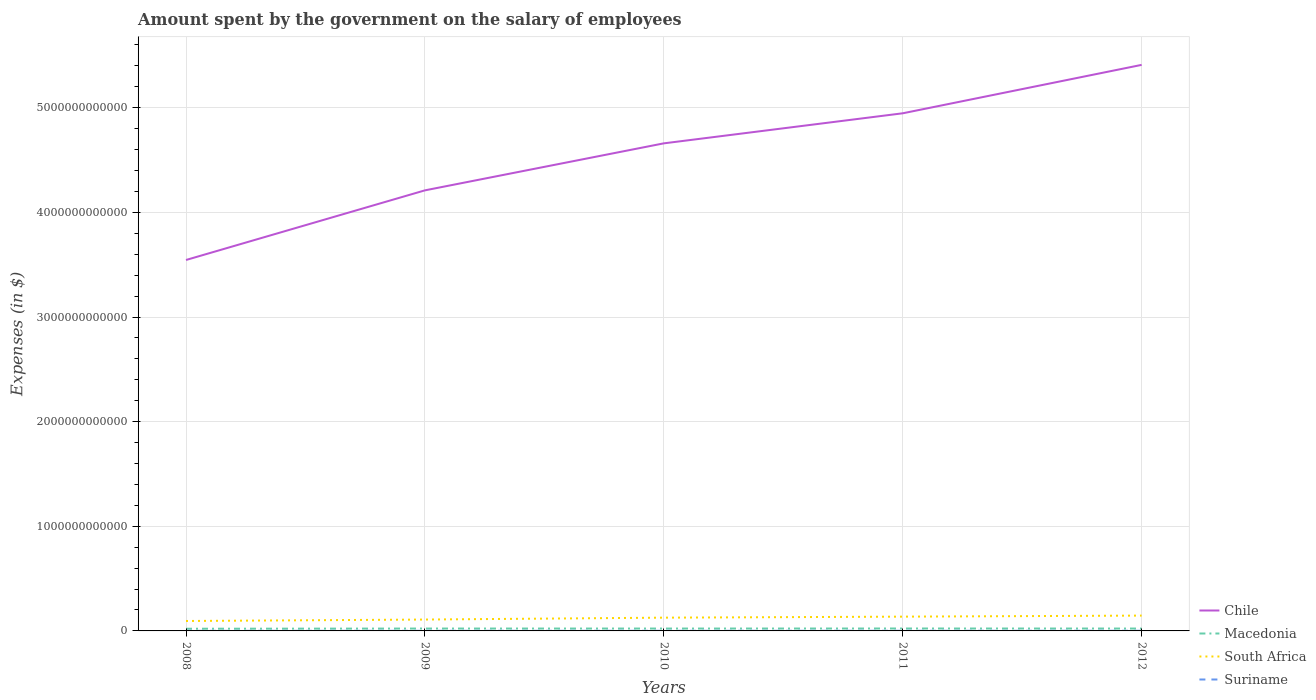Across all years, what is the maximum amount spent on the salary of employees by the government in Suriname?
Your answer should be very brief. 7.59e+08. What is the total amount spent on the salary of employees by the government in Chile in the graph?
Your response must be concise. -4.49e+11. What is the difference between the highest and the second highest amount spent on the salary of employees by the government in Macedonia?
Your answer should be very brief. 2.32e+09. What is the difference between the highest and the lowest amount spent on the salary of employees by the government in South Africa?
Make the answer very short. 3. Is the amount spent on the salary of employees by the government in Suriname strictly greater than the amount spent on the salary of employees by the government in Chile over the years?
Ensure brevity in your answer.  Yes. How many years are there in the graph?
Provide a short and direct response. 5. What is the difference between two consecutive major ticks on the Y-axis?
Provide a short and direct response. 1.00e+12. Are the values on the major ticks of Y-axis written in scientific E-notation?
Your response must be concise. No. What is the title of the graph?
Make the answer very short. Amount spent by the government on the salary of employees. Does "North America" appear as one of the legend labels in the graph?
Offer a terse response. No. What is the label or title of the Y-axis?
Make the answer very short. Expenses (in $). What is the Expenses (in $) in Chile in 2008?
Offer a terse response. 3.54e+12. What is the Expenses (in $) of Macedonia in 2008?
Keep it short and to the point. 2.08e+1. What is the Expenses (in $) of South Africa in 2008?
Give a very brief answer. 9.49e+1. What is the Expenses (in $) in Suriname in 2008?
Offer a terse response. 7.59e+08. What is the Expenses (in $) of Chile in 2009?
Make the answer very short. 4.21e+12. What is the Expenses (in $) in Macedonia in 2009?
Your answer should be compact. 2.27e+1. What is the Expenses (in $) of South Africa in 2009?
Ensure brevity in your answer.  1.09e+11. What is the Expenses (in $) in Suriname in 2009?
Keep it short and to the point. 9.68e+08. What is the Expenses (in $) of Chile in 2010?
Ensure brevity in your answer.  4.66e+12. What is the Expenses (in $) in Macedonia in 2010?
Ensure brevity in your answer.  2.26e+1. What is the Expenses (in $) of South Africa in 2010?
Provide a succinct answer. 1.27e+11. What is the Expenses (in $) in Suriname in 2010?
Provide a succinct answer. 1.08e+09. What is the Expenses (in $) of Chile in 2011?
Your answer should be very brief. 4.95e+12. What is the Expenses (in $) in Macedonia in 2011?
Your response must be concise. 2.31e+1. What is the Expenses (in $) of South Africa in 2011?
Make the answer very short. 1.36e+11. What is the Expenses (in $) in Suriname in 2011?
Offer a very short reply. 1.21e+09. What is the Expenses (in $) in Chile in 2012?
Provide a short and direct response. 5.41e+12. What is the Expenses (in $) of Macedonia in 2012?
Offer a terse response. 2.27e+1. What is the Expenses (in $) of South Africa in 2012?
Give a very brief answer. 1.47e+11. What is the Expenses (in $) of Suriname in 2012?
Provide a short and direct response. 1.32e+09. Across all years, what is the maximum Expenses (in $) of Chile?
Keep it short and to the point. 5.41e+12. Across all years, what is the maximum Expenses (in $) in Macedonia?
Keep it short and to the point. 2.31e+1. Across all years, what is the maximum Expenses (in $) of South Africa?
Your answer should be compact. 1.47e+11. Across all years, what is the maximum Expenses (in $) of Suriname?
Your answer should be compact. 1.32e+09. Across all years, what is the minimum Expenses (in $) of Chile?
Ensure brevity in your answer.  3.54e+12. Across all years, what is the minimum Expenses (in $) in Macedonia?
Keep it short and to the point. 2.08e+1. Across all years, what is the minimum Expenses (in $) of South Africa?
Offer a terse response. 9.49e+1. Across all years, what is the minimum Expenses (in $) in Suriname?
Keep it short and to the point. 7.59e+08. What is the total Expenses (in $) of Chile in the graph?
Offer a terse response. 2.28e+13. What is the total Expenses (in $) in Macedonia in the graph?
Ensure brevity in your answer.  1.12e+11. What is the total Expenses (in $) of South Africa in the graph?
Give a very brief answer. 6.13e+11. What is the total Expenses (in $) of Suriname in the graph?
Keep it short and to the point. 5.33e+09. What is the difference between the Expenses (in $) of Chile in 2008 and that in 2009?
Your answer should be compact. -6.66e+11. What is the difference between the Expenses (in $) in Macedonia in 2008 and that in 2009?
Give a very brief answer. -1.87e+09. What is the difference between the Expenses (in $) of South Africa in 2008 and that in 2009?
Offer a very short reply. -1.38e+1. What is the difference between the Expenses (in $) in Suriname in 2008 and that in 2009?
Your answer should be compact. -2.09e+08. What is the difference between the Expenses (in $) in Chile in 2008 and that in 2010?
Offer a terse response. -1.11e+12. What is the difference between the Expenses (in $) of Macedonia in 2008 and that in 2010?
Your answer should be very brief. -1.81e+09. What is the difference between the Expenses (in $) of South Africa in 2008 and that in 2010?
Provide a succinct answer. -3.18e+1. What is the difference between the Expenses (in $) in Suriname in 2008 and that in 2010?
Provide a succinct answer. -3.17e+08. What is the difference between the Expenses (in $) in Chile in 2008 and that in 2011?
Ensure brevity in your answer.  -1.40e+12. What is the difference between the Expenses (in $) of Macedonia in 2008 and that in 2011?
Offer a terse response. -2.32e+09. What is the difference between the Expenses (in $) in South Africa in 2008 and that in 2011?
Offer a terse response. -4.15e+1. What is the difference between the Expenses (in $) of Suriname in 2008 and that in 2011?
Provide a short and direct response. -4.50e+08. What is the difference between the Expenses (in $) of Chile in 2008 and that in 2012?
Offer a terse response. -1.86e+12. What is the difference between the Expenses (in $) of Macedonia in 2008 and that in 2012?
Give a very brief answer. -1.89e+09. What is the difference between the Expenses (in $) in South Africa in 2008 and that in 2012?
Your answer should be very brief. -5.16e+1. What is the difference between the Expenses (in $) in Suriname in 2008 and that in 2012?
Your answer should be very brief. -5.57e+08. What is the difference between the Expenses (in $) of Chile in 2009 and that in 2010?
Your response must be concise. -4.49e+11. What is the difference between the Expenses (in $) of Macedonia in 2009 and that in 2010?
Give a very brief answer. 6.10e+07. What is the difference between the Expenses (in $) of South Africa in 2009 and that in 2010?
Keep it short and to the point. -1.81e+1. What is the difference between the Expenses (in $) in Suriname in 2009 and that in 2010?
Give a very brief answer. -1.07e+08. What is the difference between the Expenses (in $) in Chile in 2009 and that in 2011?
Your answer should be compact. -7.36e+11. What is the difference between the Expenses (in $) in Macedonia in 2009 and that in 2011?
Offer a terse response. -4.48e+08. What is the difference between the Expenses (in $) in South Africa in 2009 and that in 2011?
Make the answer very short. -2.78e+1. What is the difference between the Expenses (in $) of Suriname in 2009 and that in 2011?
Ensure brevity in your answer.  -2.41e+08. What is the difference between the Expenses (in $) of Chile in 2009 and that in 2012?
Provide a short and direct response. -1.20e+12. What is the difference between the Expenses (in $) in Macedonia in 2009 and that in 2012?
Offer a very short reply. -1.50e+07. What is the difference between the Expenses (in $) of South Africa in 2009 and that in 2012?
Provide a short and direct response. -3.78e+1. What is the difference between the Expenses (in $) in Suriname in 2009 and that in 2012?
Your response must be concise. -3.48e+08. What is the difference between the Expenses (in $) in Chile in 2010 and that in 2011?
Offer a terse response. -2.87e+11. What is the difference between the Expenses (in $) of Macedonia in 2010 and that in 2011?
Provide a short and direct response. -5.09e+08. What is the difference between the Expenses (in $) of South Africa in 2010 and that in 2011?
Keep it short and to the point. -9.72e+09. What is the difference between the Expenses (in $) in Suriname in 2010 and that in 2011?
Make the answer very short. -1.34e+08. What is the difference between the Expenses (in $) in Chile in 2010 and that in 2012?
Give a very brief answer. -7.50e+11. What is the difference between the Expenses (in $) in Macedonia in 2010 and that in 2012?
Offer a very short reply. -7.60e+07. What is the difference between the Expenses (in $) in South Africa in 2010 and that in 2012?
Make the answer very short. -1.98e+1. What is the difference between the Expenses (in $) of Suriname in 2010 and that in 2012?
Make the answer very short. -2.40e+08. What is the difference between the Expenses (in $) of Chile in 2011 and that in 2012?
Ensure brevity in your answer.  -4.63e+11. What is the difference between the Expenses (in $) in Macedonia in 2011 and that in 2012?
Keep it short and to the point. 4.33e+08. What is the difference between the Expenses (in $) of South Africa in 2011 and that in 2012?
Offer a very short reply. -1.01e+1. What is the difference between the Expenses (in $) in Suriname in 2011 and that in 2012?
Your response must be concise. -1.07e+08. What is the difference between the Expenses (in $) in Chile in 2008 and the Expenses (in $) in Macedonia in 2009?
Offer a terse response. 3.52e+12. What is the difference between the Expenses (in $) of Chile in 2008 and the Expenses (in $) of South Africa in 2009?
Your response must be concise. 3.44e+12. What is the difference between the Expenses (in $) in Chile in 2008 and the Expenses (in $) in Suriname in 2009?
Your answer should be compact. 3.54e+12. What is the difference between the Expenses (in $) in Macedonia in 2008 and the Expenses (in $) in South Africa in 2009?
Give a very brief answer. -8.79e+1. What is the difference between the Expenses (in $) of Macedonia in 2008 and the Expenses (in $) of Suriname in 2009?
Provide a short and direct response. 1.99e+1. What is the difference between the Expenses (in $) of South Africa in 2008 and the Expenses (in $) of Suriname in 2009?
Keep it short and to the point. 9.40e+1. What is the difference between the Expenses (in $) in Chile in 2008 and the Expenses (in $) in Macedonia in 2010?
Your answer should be compact. 3.52e+12. What is the difference between the Expenses (in $) in Chile in 2008 and the Expenses (in $) in South Africa in 2010?
Give a very brief answer. 3.42e+12. What is the difference between the Expenses (in $) of Chile in 2008 and the Expenses (in $) of Suriname in 2010?
Provide a succinct answer. 3.54e+12. What is the difference between the Expenses (in $) in Macedonia in 2008 and the Expenses (in $) in South Africa in 2010?
Provide a short and direct response. -1.06e+11. What is the difference between the Expenses (in $) of Macedonia in 2008 and the Expenses (in $) of Suriname in 2010?
Give a very brief answer. 1.98e+1. What is the difference between the Expenses (in $) of South Africa in 2008 and the Expenses (in $) of Suriname in 2010?
Make the answer very short. 9.39e+1. What is the difference between the Expenses (in $) of Chile in 2008 and the Expenses (in $) of Macedonia in 2011?
Your response must be concise. 3.52e+12. What is the difference between the Expenses (in $) in Chile in 2008 and the Expenses (in $) in South Africa in 2011?
Offer a very short reply. 3.41e+12. What is the difference between the Expenses (in $) of Chile in 2008 and the Expenses (in $) of Suriname in 2011?
Ensure brevity in your answer.  3.54e+12. What is the difference between the Expenses (in $) in Macedonia in 2008 and the Expenses (in $) in South Africa in 2011?
Give a very brief answer. -1.16e+11. What is the difference between the Expenses (in $) of Macedonia in 2008 and the Expenses (in $) of Suriname in 2011?
Your answer should be compact. 1.96e+1. What is the difference between the Expenses (in $) in South Africa in 2008 and the Expenses (in $) in Suriname in 2011?
Your answer should be very brief. 9.37e+1. What is the difference between the Expenses (in $) of Chile in 2008 and the Expenses (in $) of Macedonia in 2012?
Offer a very short reply. 3.52e+12. What is the difference between the Expenses (in $) of Chile in 2008 and the Expenses (in $) of South Africa in 2012?
Provide a short and direct response. 3.40e+12. What is the difference between the Expenses (in $) of Chile in 2008 and the Expenses (in $) of Suriname in 2012?
Provide a succinct answer. 3.54e+12. What is the difference between the Expenses (in $) of Macedonia in 2008 and the Expenses (in $) of South Africa in 2012?
Your answer should be compact. -1.26e+11. What is the difference between the Expenses (in $) of Macedonia in 2008 and the Expenses (in $) of Suriname in 2012?
Your answer should be compact. 1.95e+1. What is the difference between the Expenses (in $) in South Africa in 2008 and the Expenses (in $) in Suriname in 2012?
Keep it short and to the point. 9.36e+1. What is the difference between the Expenses (in $) in Chile in 2009 and the Expenses (in $) in Macedonia in 2010?
Provide a succinct answer. 4.19e+12. What is the difference between the Expenses (in $) in Chile in 2009 and the Expenses (in $) in South Africa in 2010?
Provide a short and direct response. 4.08e+12. What is the difference between the Expenses (in $) in Chile in 2009 and the Expenses (in $) in Suriname in 2010?
Offer a very short reply. 4.21e+12. What is the difference between the Expenses (in $) in Macedonia in 2009 and the Expenses (in $) in South Africa in 2010?
Your answer should be very brief. -1.04e+11. What is the difference between the Expenses (in $) of Macedonia in 2009 and the Expenses (in $) of Suriname in 2010?
Your answer should be compact. 2.16e+1. What is the difference between the Expenses (in $) in South Africa in 2009 and the Expenses (in $) in Suriname in 2010?
Provide a short and direct response. 1.08e+11. What is the difference between the Expenses (in $) in Chile in 2009 and the Expenses (in $) in Macedonia in 2011?
Give a very brief answer. 4.19e+12. What is the difference between the Expenses (in $) of Chile in 2009 and the Expenses (in $) of South Africa in 2011?
Give a very brief answer. 4.07e+12. What is the difference between the Expenses (in $) of Chile in 2009 and the Expenses (in $) of Suriname in 2011?
Make the answer very short. 4.21e+12. What is the difference between the Expenses (in $) in Macedonia in 2009 and the Expenses (in $) in South Africa in 2011?
Provide a short and direct response. -1.14e+11. What is the difference between the Expenses (in $) in Macedonia in 2009 and the Expenses (in $) in Suriname in 2011?
Your answer should be very brief. 2.15e+1. What is the difference between the Expenses (in $) of South Africa in 2009 and the Expenses (in $) of Suriname in 2011?
Provide a short and direct response. 1.07e+11. What is the difference between the Expenses (in $) of Chile in 2009 and the Expenses (in $) of Macedonia in 2012?
Your answer should be compact. 4.19e+12. What is the difference between the Expenses (in $) of Chile in 2009 and the Expenses (in $) of South Africa in 2012?
Ensure brevity in your answer.  4.06e+12. What is the difference between the Expenses (in $) of Chile in 2009 and the Expenses (in $) of Suriname in 2012?
Offer a very short reply. 4.21e+12. What is the difference between the Expenses (in $) of Macedonia in 2009 and the Expenses (in $) of South Africa in 2012?
Provide a short and direct response. -1.24e+11. What is the difference between the Expenses (in $) in Macedonia in 2009 and the Expenses (in $) in Suriname in 2012?
Your answer should be very brief. 2.14e+1. What is the difference between the Expenses (in $) of South Africa in 2009 and the Expenses (in $) of Suriname in 2012?
Your answer should be very brief. 1.07e+11. What is the difference between the Expenses (in $) of Chile in 2010 and the Expenses (in $) of Macedonia in 2011?
Provide a short and direct response. 4.64e+12. What is the difference between the Expenses (in $) in Chile in 2010 and the Expenses (in $) in South Africa in 2011?
Ensure brevity in your answer.  4.52e+12. What is the difference between the Expenses (in $) in Chile in 2010 and the Expenses (in $) in Suriname in 2011?
Your answer should be very brief. 4.66e+12. What is the difference between the Expenses (in $) of Macedonia in 2010 and the Expenses (in $) of South Africa in 2011?
Ensure brevity in your answer.  -1.14e+11. What is the difference between the Expenses (in $) of Macedonia in 2010 and the Expenses (in $) of Suriname in 2011?
Make the answer very short. 2.14e+1. What is the difference between the Expenses (in $) in South Africa in 2010 and the Expenses (in $) in Suriname in 2011?
Your response must be concise. 1.26e+11. What is the difference between the Expenses (in $) of Chile in 2010 and the Expenses (in $) of Macedonia in 2012?
Your answer should be very brief. 4.64e+12. What is the difference between the Expenses (in $) in Chile in 2010 and the Expenses (in $) in South Africa in 2012?
Offer a terse response. 4.51e+12. What is the difference between the Expenses (in $) of Chile in 2010 and the Expenses (in $) of Suriname in 2012?
Ensure brevity in your answer.  4.66e+12. What is the difference between the Expenses (in $) in Macedonia in 2010 and the Expenses (in $) in South Africa in 2012?
Your answer should be compact. -1.24e+11. What is the difference between the Expenses (in $) in Macedonia in 2010 and the Expenses (in $) in Suriname in 2012?
Your response must be concise. 2.13e+1. What is the difference between the Expenses (in $) in South Africa in 2010 and the Expenses (in $) in Suriname in 2012?
Provide a short and direct response. 1.25e+11. What is the difference between the Expenses (in $) in Chile in 2011 and the Expenses (in $) in Macedonia in 2012?
Ensure brevity in your answer.  4.92e+12. What is the difference between the Expenses (in $) of Chile in 2011 and the Expenses (in $) of South Africa in 2012?
Provide a short and direct response. 4.80e+12. What is the difference between the Expenses (in $) of Chile in 2011 and the Expenses (in $) of Suriname in 2012?
Provide a succinct answer. 4.95e+12. What is the difference between the Expenses (in $) of Macedonia in 2011 and the Expenses (in $) of South Africa in 2012?
Your response must be concise. -1.23e+11. What is the difference between the Expenses (in $) in Macedonia in 2011 and the Expenses (in $) in Suriname in 2012?
Ensure brevity in your answer.  2.18e+1. What is the difference between the Expenses (in $) of South Africa in 2011 and the Expenses (in $) of Suriname in 2012?
Make the answer very short. 1.35e+11. What is the average Expenses (in $) in Chile per year?
Offer a very short reply. 4.55e+12. What is the average Expenses (in $) of Macedonia per year?
Ensure brevity in your answer.  2.24e+1. What is the average Expenses (in $) of South Africa per year?
Keep it short and to the point. 1.23e+11. What is the average Expenses (in $) in Suriname per year?
Keep it short and to the point. 1.07e+09. In the year 2008, what is the difference between the Expenses (in $) in Chile and Expenses (in $) in Macedonia?
Make the answer very short. 3.52e+12. In the year 2008, what is the difference between the Expenses (in $) in Chile and Expenses (in $) in South Africa?
Make the answer very short. 3.45e+12. In the year 2008, what is the difference between the Expenses (in $) in Chile and Expenses (in $) in Suriname?
Make the answer very short. 3.54e+12. In the year 2008, what is the difference between the Expenses (in $) in Macedonia and Expenses (in $) in South Africa?
Your answer should be compact. -7.41e+1. In the year 2008, what is the difference between the Expenses (in $) of Macedonia and Expenses (in $) of Suriname?
Ensure brevity in your answer.  2.01e+1. In the year 2008, what is the difference between the Expenses (in $) of South Africa and Expenses (in $) of Suriname?
Offer a very short reply. 9.42e+1. In the year 2009, what is the difference between the Expenses (in $) of Chile and Expenses (in $) of Macedonia?
Provide a succinct answer. 4.19e+12. In the year 2009, what is the difference between the Expenses (in $) of Chile and Expenses (in $) of South Africa?
Offer a terse response. 4.10e+12. In the year 2009, what is the difference between the Expenses (in $) of Chile and Expenses (in $) of Suriname?
Keep it short and to the point. 4.21e+12. In the year 2009, what is the difference between the Expenses (in $) of Macedonia and Expenses (in $) of South Africa?
Give a very brief answer. -8.60e+1. In the year 2009, what is the difference between the Expenses (in $) in Macedonia and Expenses (in $) in Suriname?
Your answer should be very brief. 2.17e+1. In the year 2009, what is the difference between the Expenses (in $) of South Africa and Expenses (in $) of Suriname?
Offer a very short reply. 1.08e+11. In the year 2010, what is the difference between the Expenses (in $) of Chile and Expenses (in $) of Macedonia?
Offer a very short reply. 4.64e+12. In the year 2010, what is the difference between the Expenses (in $) in Chile and Expenses (in $) in South Africa?
Your response must be concise. 4.53e+12. In the year 2010, what is the difference between the Expenses (in $) of Chile and Expenses (in $) of Suriname?
Make the answer very short. 4.66e+12. In the year 2010, what is the difference between the Expenses (in $) of Macedonia and Expenses (in $) of South Africa?
Provide a short and direct response. -1.04e+11. In the year 2010, what is the difference between the Expenses (in $) in Macedonia and Expenses (in $) in Suriname?
Your answer should be compact. 2.16e+1. In the year 2010, what is the difference between the Expenses (in $) of South Africa and Expenses (in $) of Suriname?
Keep it short and to the point. 1.26e+11. In the year 2011, what is the difference between the Expenses (in $) of Chile and Expenses (in $) of Macedonia?
Ensure brevity in your answer.  4.92e+12. In the year 2011, what is the difference between the Expenses (in $) of Chile and Expenses (in $) of South Africa?
Offer a very short reply. 4.81e+12. In the year 2011, what is the difference between the Expenses (in $) of Chile and Expenses (in $) of Suriname?
Offer a very short reply. 4.95e+12. In the year 2011, what is the difference between the Expenses (in $) of Macedonia and Expenses (in $) of South Africa?
Offer a terse response. -1.13e+11. In the year 2011, what is the difference between the Expenses (in $) in Macedonia and Expenses (in $) in Suriname?
Offer a terse response. 2.19e+1. In the year 2011, what is the difference between the Expenses (in $) in South Africa and Expenses (in $) in Suriname?
Give a very brief answer. 1.35e+11. In the year 2012, what is the difference between the Expenses (in $) in Chile and Expenses (in $) in Macedonia?
Make the answer very short. 5.39e+12. In the year 2012, what is the difference between the Expenses (in $) of Chile and Expenses (in $) of South Africa?
Provide a succinct answer. 5.26e+12. In the year 2012, what is the difference between the Expenses (in $) in Chile and Expenses (in $) in Suriname?
Offer a terse response. 5.41e+12. In the year 2012, what is the difference between the Expenses (in $) of Macedonia and Expenses (in $) of South Africa?
Keep it short and to the point. -1.24e+11. In the year 2012, what is the difference between the Expenses (in $) in Macedonia and Expenses (in $) in Suriname?
Give a very brief answer. 2.14e+1. In the year 2012, what is the difference between the Expenses (in $) of South Africa and Expenses (in $) of Suriname?
Your response must be concise. 1.45e+11. What is the ratio of the Expenses (in $) in Chile in 2008 to that in 2009?
Give a very brief answer. 0.84. What is the ratio of the Expenses (in $) in Macedonia in 2008 to that in 2009?
Ensure brevity in your answer.  0.92. What is the ratio of the Expenses (in $) in South Africa in 2008 to that in 2009?
Provide a short and direct response. 0.87. What is the ratio of the Expenses (in $) in Suriname in 2008 to that in 2009?
Ensure brevity in your answer.  0.78. What is the ratio of the Expenses (in $) in Chile in 2008 to that in 2010?
Your response must be concise. 0.76. What is the ratio of the Expenses (in $) in Macedonia in 2008 to that in 2010?
Your answer should be very brief. 0.92. What is the ratio of the Expenses (in $) in South Africa in 2008 to that in 2010?
Your response must be concise. 0.75. What is the ratio of the Expenses (in $) in Suriname in 2008 to that in 2010?
Offer a very short reply. 0.71. What is the ratio of the Expenses (in $) in Chile in 2008 to that in 2011?
Make the answer very short. 0.72. What is the ratio of the Expenses (in $) in Macedonia in 2008 to that in 2011?
Make the answer very short. 0.9. What is the ratio of the Expenses (in $) of South Africa in 2008 to that in 2011?
Make the answer very short. 0.7. What is the ratio of the Expenses (in $) of Suriname in 2008 to that in 2011?
Make the answer very short. 0.63. What is the ratio of the Expenses (in $) in Chile in 2008 to that in 2012?
Make the answer very short. 0.66. What is the ratio of the Expenses (in $) of Macedonia in 2008 to that in 2012?
Keep it short and to the point. 0.92. What is the ratio of the Expenses (in $) of South Africa in 2008 to that in 2012?
Your answer should be very brief. 0.65. What is the ratio of the Expenses (in $) of Suriname in 2008 to that in 2012?
Provide a succinct answer. 0.58. What is the ratio of the Expenses (in $) of Chile in 2009 to that in 2010?
Provide a short and direct response. 0.9. What is the ratio of the Expenses (in $) of Macedonia in 2009 to that in 2010?
Your response must be concise. 1. What is the ratio of the Expenses (in $) in South Africa in 2009 to that in 2010?
Ensure brevity in your answer.  0.86. What is the ratio of the Expenses (in $) in Suriname in 2009 to that in 2010?
Provide a succinct answer. 0.9. What is the ratio of the Expenses (in $) in Chile in 2009 to that in 2011?
Your answer should be very brief. 0.85. What is the ratio of the Expenses (in $) in Macedonia in 2009 to that in 2011?
Give a very brief answer. 0.98. What is the ratio of the Expenses (in $) in South Africa in 2009 to that in 2011?
Provide a short and direct response. 0.8. What is the ratio of the Expenses (in $) in Suriname in 2009 to that in 2011?
Offer a very short reply. 0.8. What is the ratio of the Expenses (in $) of Chile in 2009 to that in 2012?
Your answer should be compact. 0.78. What is the ratio of the Expenses (in $) of South Africa in 2009 to that in 2012?
Provide a succinct answer. 0.74. What is the ratio of the Expenses (in $) in Suriname in 2009 to that in 2012?
Ensure brevity in your answer.  0.74. What is the ratio of the Expenses (in $) in Chile in 2010 to that in 2011?
Provide a short and direct response. 0.94. What is the ratio of the Expenses (in $) in South Africa in 2010 to that in 2011?
Give a very brief answer. 0.93. What is the ratio of the Expenses (in $) in Suriname in 2010 to that in 2011?
Keep it short and to the point. 0.89. What is the ratio of the Expenses (in $) of Chile in 2010 to that in 2012?
Provide a short and direct response. 0.86. What is the ratio of the Expenses (in $) of Macedonia in 2010 to that in 2012?
Provide a short and direct response. 1. What is the ratio of the Expenses (in $) of South Africa in 2010 to that in 2012?
Provide a succinct answer. 0.87. What is the ratio of the Expenses (in $) in Suriname in 2010 to that in 2012?
Your response must be concise. 0.82. What is the ratio of the Expenses (in $) of Chile in 2011 to that in 2012?
Offer a very short reply. 0.91. What is the ratio of the Expenses (in $) in Macedonia in 2011 to that in 2012?
Your response must be concise. 1.02. What is the ratio of the Expenses (in $) in South Africa in 2011 to that in 2012?
Offer a very short reply. 0.93. What is the ratio of the Expenses (in $) of Suriname in 2011 to that in 2012?
Your answer should be very brief. 0.92. What is the difference between the highest and the second highest Expenses (in $) in Chile?
Keep it short and to the point. 4.63e+11. What is the difference between the highest and the second highest Expenses (in $) in Macedonia?
Ensure brevity in your answer.  4.33e+08. What is the difference between the highest and the second highest Expenses (in $) of South Africa?
Offer a terse response. 1.01e+1. What is the difference between the highest and the second highest Expenses (in $) in Suriname?
Ensure brevity in your answer.  1.07e+08. What is the difference between the highest and the lowest Expenses (in $) of Chile?
Your answer should be compact. 1.86e+12. What is the difference between the highest and the lowest Expenses (in $) of Macedonia?
Your answer should be compact. 2.32e+09. What is the difference between the highest and the lowest Expenses (in $) of South Africa?
Your response must be concise. 5.16e+1. What is the difference between the highest and the lowest Expenses (in $) of Suriname?
Ensure brevity in your answer.  5.57e+08. 